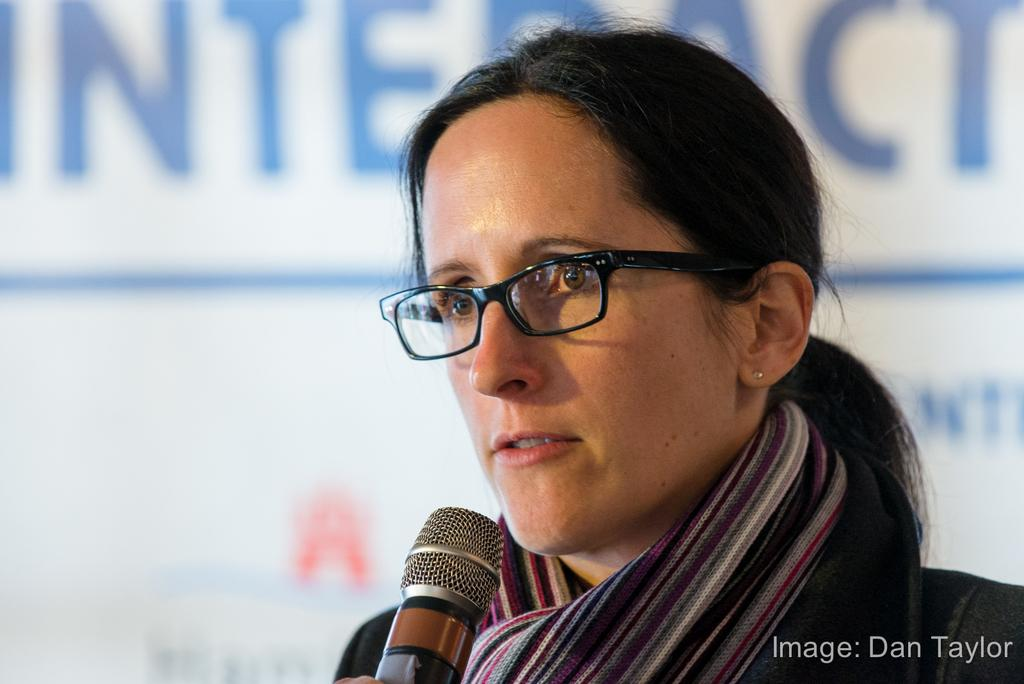Who is present in the image? There is a woman in the image. What is the woman doing? The woman is speaking. What color is the background of the image? The background of the image is blue. Is there any text visible in the image? Yes, there is text in the bottom right corner of the image. What type of badge is the woman wearing in the image? There is no badge visible in the image. Can you describe the stone structure in the background of the image? There is no stone structure present in the image; the background is blue. 